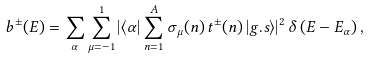<formula> <loc_0><loc_0><loc_500><loc_500>b ^ { \pm } ( E ) = \sum _ { \alpha } \sum _ { \mu = - 1 } ^ { 1 } \left | \langle \alpha \right | \sum _ { n = 1 } ^ { A } \sigma _ { \mu } ( n ) \, t ^ { \pm } ( n ) \left | g . s \rangle \right | ^ { 2 } \delta \left ( E - E _ { \alpha } \right ) ,</formula> 